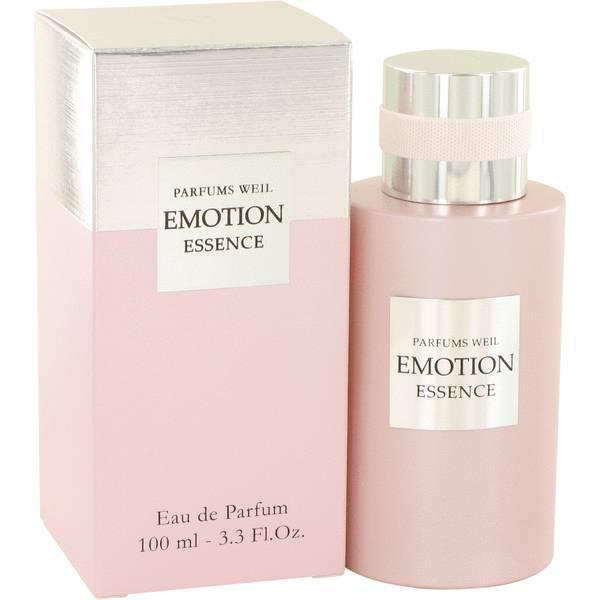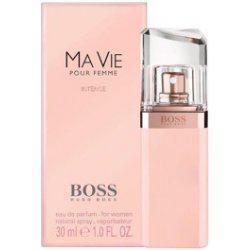The first image is the image on the left, the second image is the image on the right. For the images shown, is this caption "There is a bottle of perfume without a box next to it." true? Answer yes or no. No. 